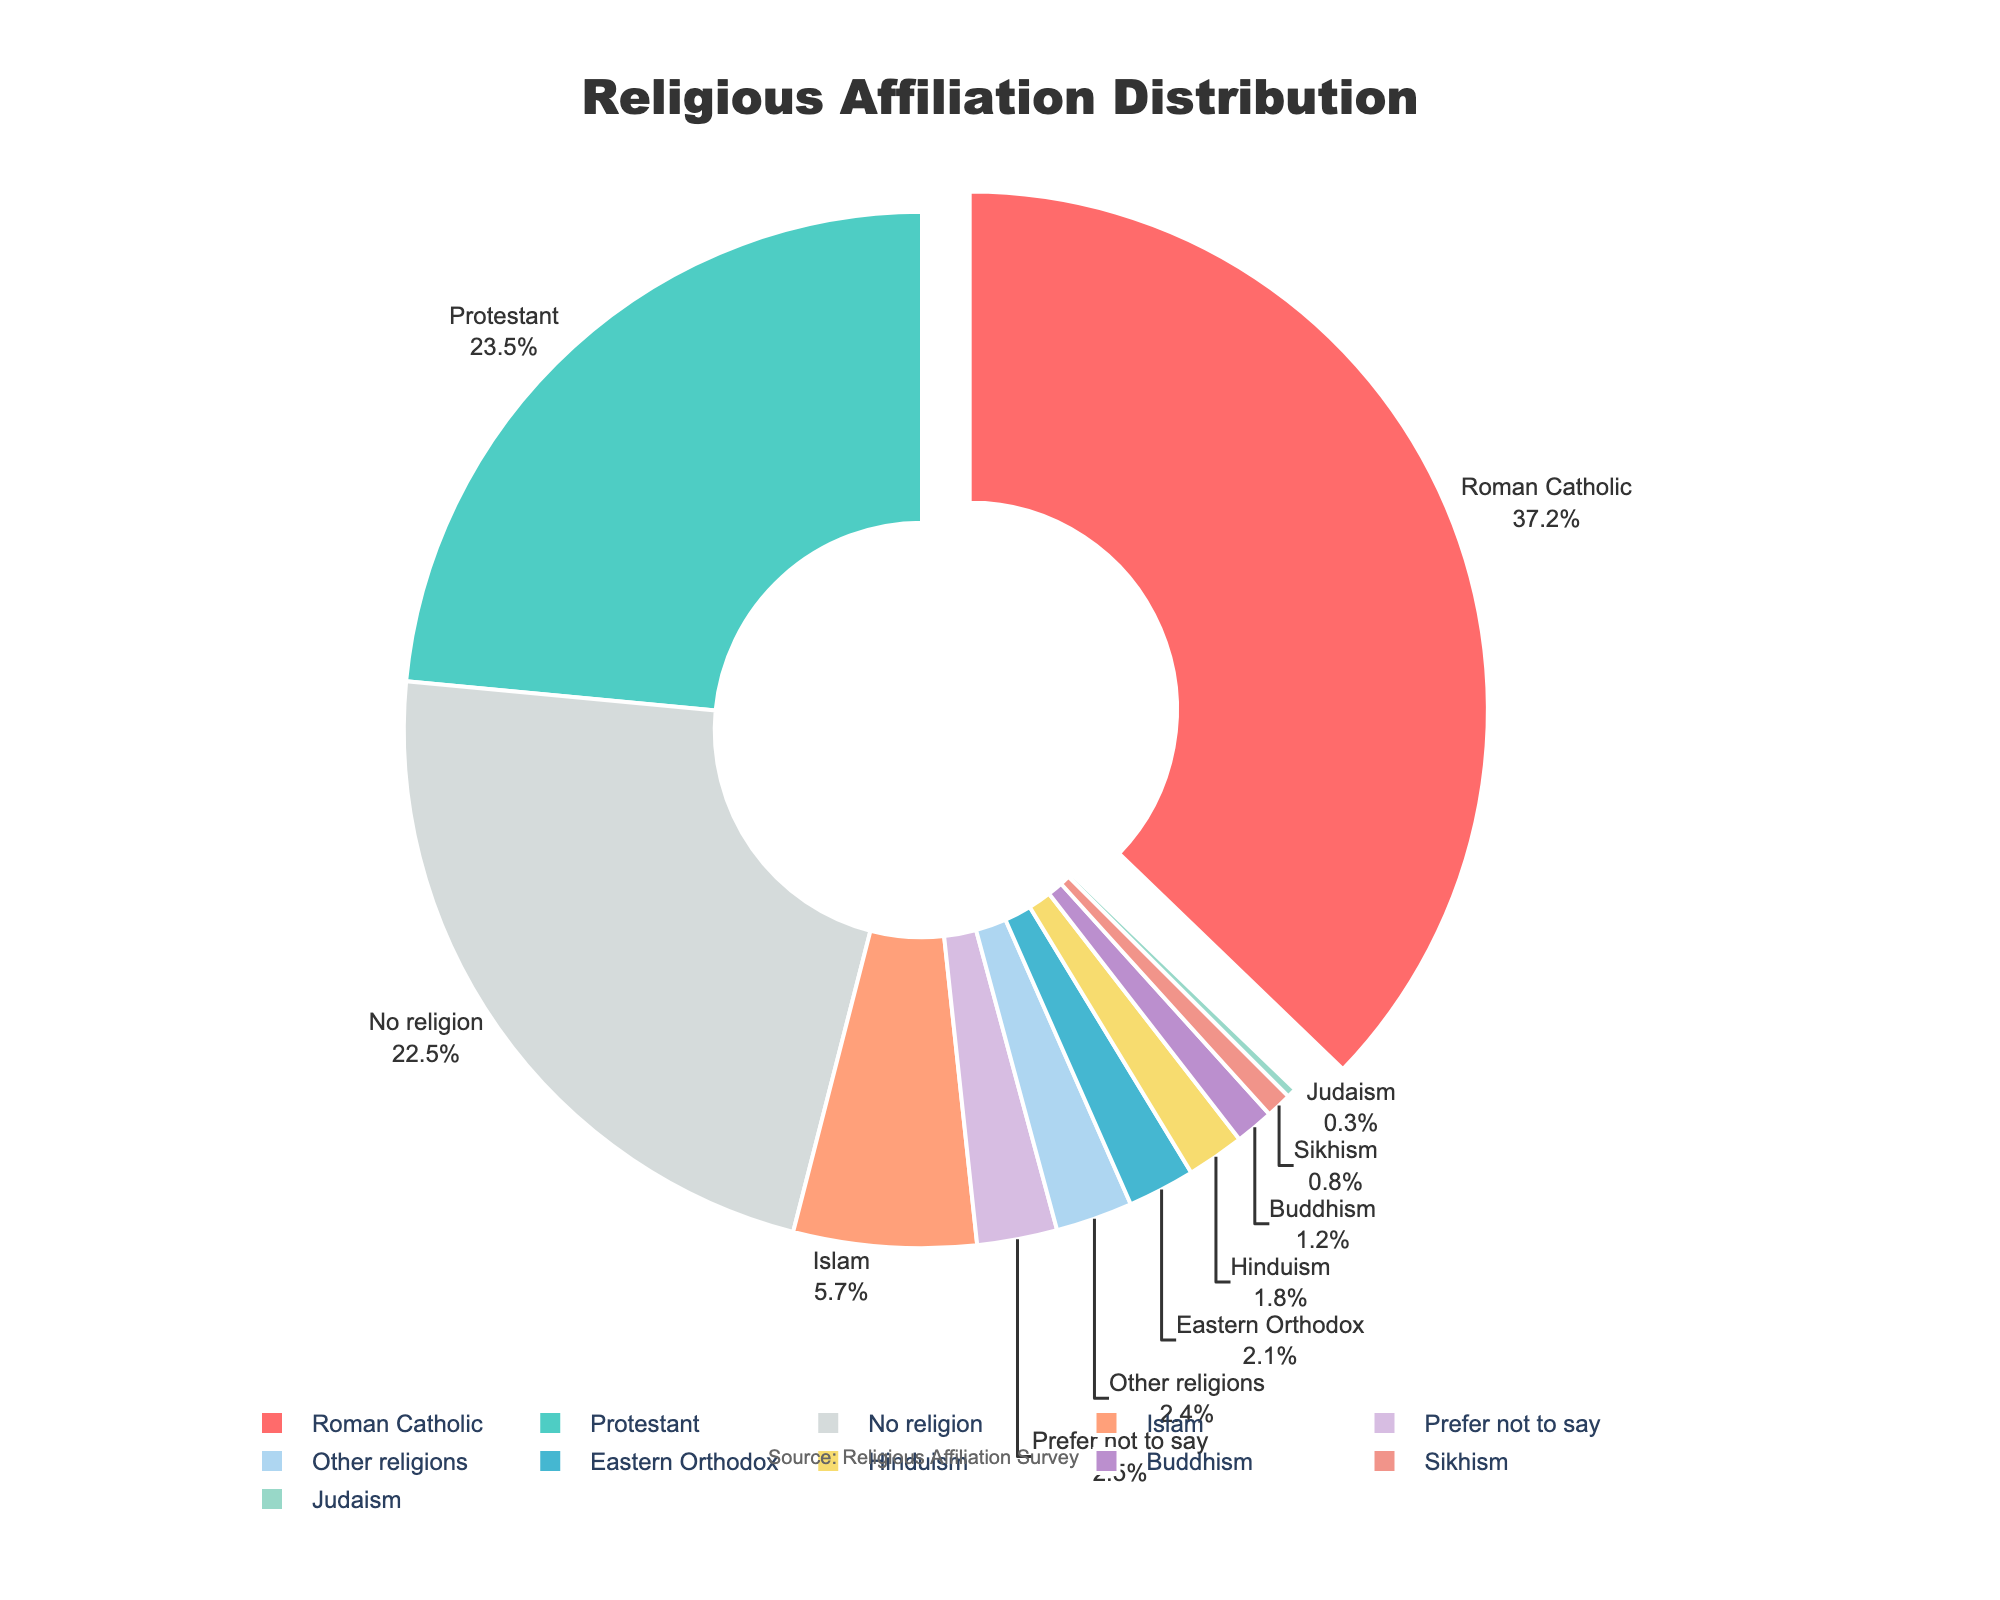What is the percentage of people who identify as Roman Catholic? The pie chart directly shows the percentage of people who identify as Roman Catholic, which is the largest section, pulled out slightly from the pie to emphasize its size.
Answer: 37.2% What is the combined percentage of people who identify as Protestant and Eastern Orthodox? Sum the percentages for Protestant and Eastern Orthodox: 23.5% + 2.1% = 25.6%.
Answer: 25.6% Which group has a higher percentage: those identifying with Eastern Orthodox or those identifying with Buddhism? Compare the percentage values of Eastern Orthodox (2.1%) and Buddhism (1.2%) directly from the pie chart. Eastern Orthodox is higher.
Answer: Eastern Orthodox What is the total percentage of people with no religion and those who prefer not to say their religious affiliation? Sum the percentages for No religion and Prefer not to say: 22.5% + 2.5% = 25%.
Answer: 25% Which religious group has the smallest percentage? The pie chart shows that Judaism has the smallest percentage at 0.3%.
Answer: Judaism How much greater is the percentage of the Protestant group compared to the Islam group? Subtract the percentage of the Islam group from the Protestant group: 23.5% - 5.7% = 17.8%.
Answer: 17.8% What percentage of the population is affiliated with all the major religions (Roman Catholic, Protestant, Eastern Orthodox, Islam, Judaism, Hinduism, Buddhism, and Sikhism) combined? Sum all the percentages of the major religious groups: 37.2% (Roman Catholic) + 23.5% (Protestant) + 2.1% (Eastern Orthodox) + 5.7% (Islam) + 0.3% (Judaism) + 1.8% (Hinduism) + 1.2% (Buddhism) + 0.8% (Sikhism) = 72.6%.
Answer: 72.6% Is the percentage of people following other religions greater or smaller than the percentage of people who prefer not to say their religion? Compare the percentages for Other religions (2.4%) and Prefer not to say (2.5%). Prefer not to say is slightly greater.
Answer: Prefer not to say What percentage of the population identifies with either Hinduism or is unaffiliated with any religion? Sum the percentages for Hinduism and No religion: 1.8% (Hinduism) + 22.5% (No religion) = 24.3%.
Answer: 24.3% 